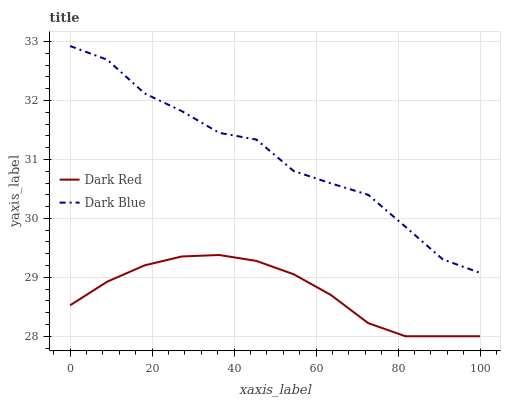Does Dark Red have the minimum area under the curve?
Answer yes or no. Yes. Does Dark Blue have the maximum area under the curve?
Answer yes or no. Yes. Does Dark Blue have the minimum area under the curve?
Answer yes or no. No. Is Dark Red the smoothest?
Answer yes or no. Yes. Is Dark Blue the roughest?
Answer yes or no. Yes. Is Dark Blue the smoothest?
Answer yes or no. No. Does Dark Blue have the lowest value?
Answer yes or no. No. Does Dark Blue have the highest value?
Answer yes or no. Yes. Is Dark Red less than Dark Blue?
Answer yes or no. Yes. Is Dark Blue greater than Dark Red?
Answer yes or no. Yes. Does Dark Red intersect Dark Blue?
Answer yes or no. No. 